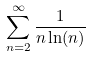<formula> <loc_0><loc_0><loc_500><loc_500>\sum _ { n = 2 } ^ { \infty } \frac { 1 } { n \ln ( n ) }</formula> 